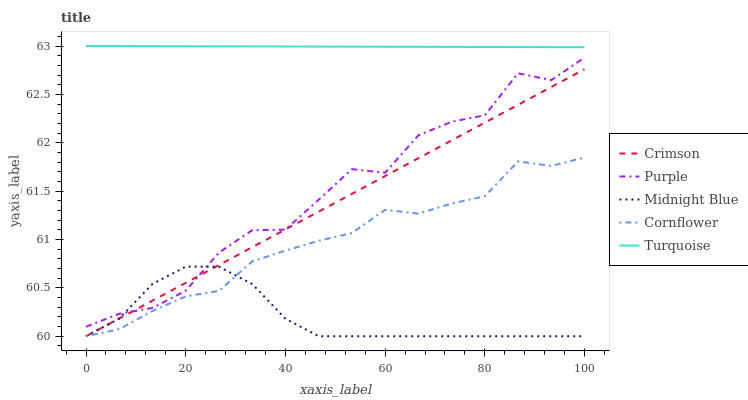Does Midnight Blue have the minimum area under the curve?
Answer yes or no. Yes. Does Turquoise have the maximum area under the curve?
Answer yes or no. Yes. Does Purple have the minimum area under the curve?
Answer yes or no. No. Does Purple have the maximum area under the curve?
Answer yes or no. No. Is Crimson the smoothest?
Answer yes or no. Yes. Is Purple the roughest?
Answer yes or no. Yes. Is Turquoise the smoothest?
Answer yes or no. No. Is Turquoise the roughest?
Answer yes or no. No. Does Purple have the lowest value?
Answer yes or no. No. Does Turquoise have the highest value?
Answer yes or no. Yes. Does Purple have the highest value?
Answer yes or no. No. Is Purple less than Turquoise?
Answer yes or no. Yes. Is Turquoise greater than Crimson?
Answer yes or no. Yes. Does Purple intersect Crimson?
Answer yes or no. Yes. Is Purple less than Crimson?
Answer yes or no. No. Is Purple greater than Crimson?
Answer yes or no. No. Does Purple intersect Turquoise?
Answer yes or no. No. 